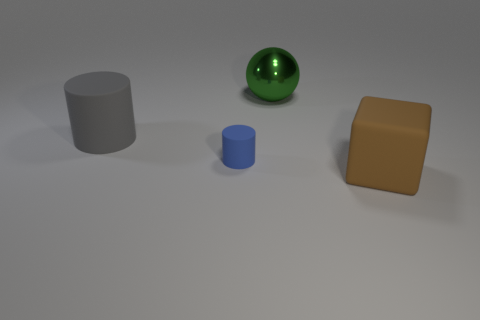Is there any other thing that has the same size as the blue rubber thing?
Your response must be concise. No. How many other objects are the same size as the brown rubber block?
Ensure brevity in your answer.  2. What size is the rubber thing that is in front of the big gray cylinder and on the left side of the big green object?
Your answer should be very brief. Small. Is the number of tiny matte things behind the small object greater than the number of big green metal objects left of the green shiny thing?
Give a very brief answer. No. The small matte thing is what color?
Your response must be concise. Blue. What color is the thing that is both in front of the large green thing and on the right side of the blue rubber thing?
Make the answer very short. Brown. What color is the big matte thing on the left side of the large thing that is in front of the big matte thing that is behind the large brown rubber object?
Ensure brevity in your answer.  Gray. There is a rubber cylinder that is the same size as the rubber block; what color is it?
Offer a terse response. Gray. There is a large rubber thing right of the cylinder that is to the right of the large matte object to the left of the large rubber cube; what shape is it?
Your answer should be very brief. Cube. What number of objects are either red metal cylinders or matte things behind the blue rubber thing?
Give a very brief answer. 1. 